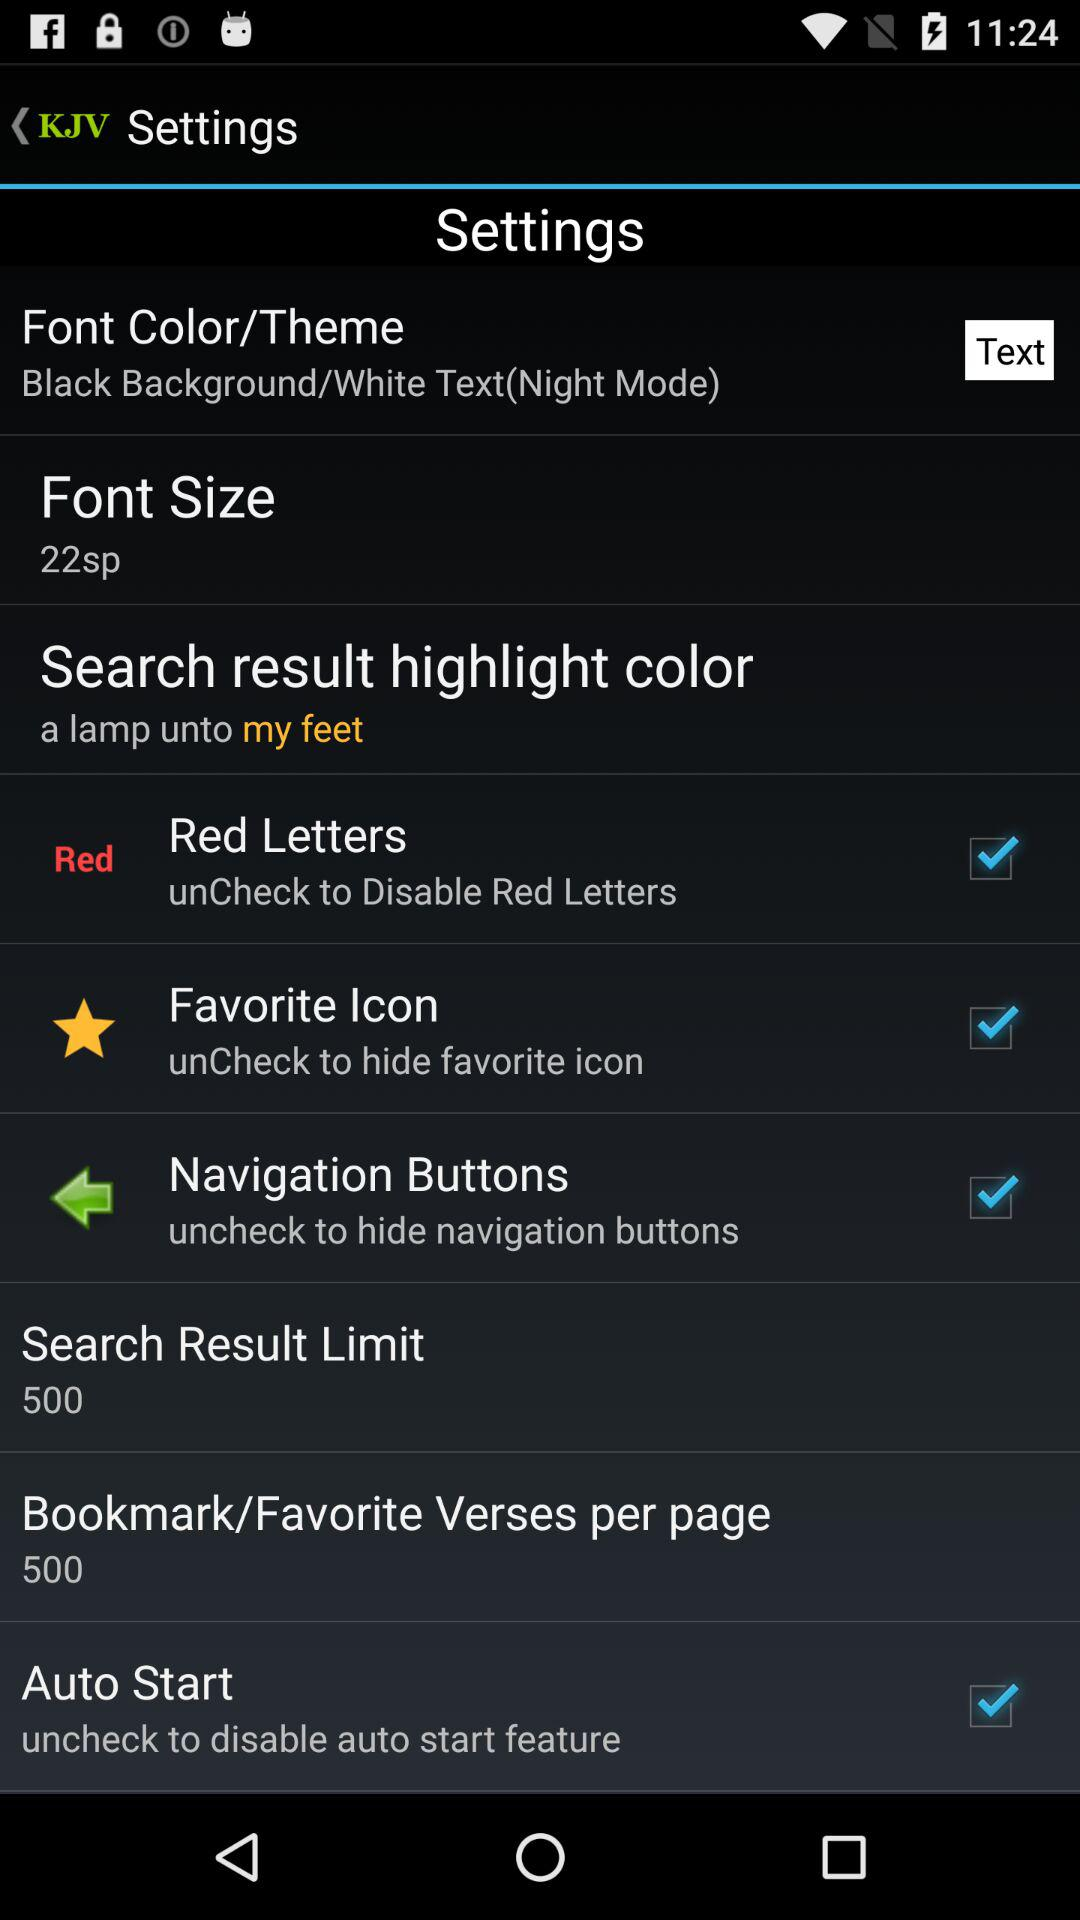What options are checked? The checked options are "Red Letters", "Favorite Icon", "Navigation Buttons" and "Auto Start". 